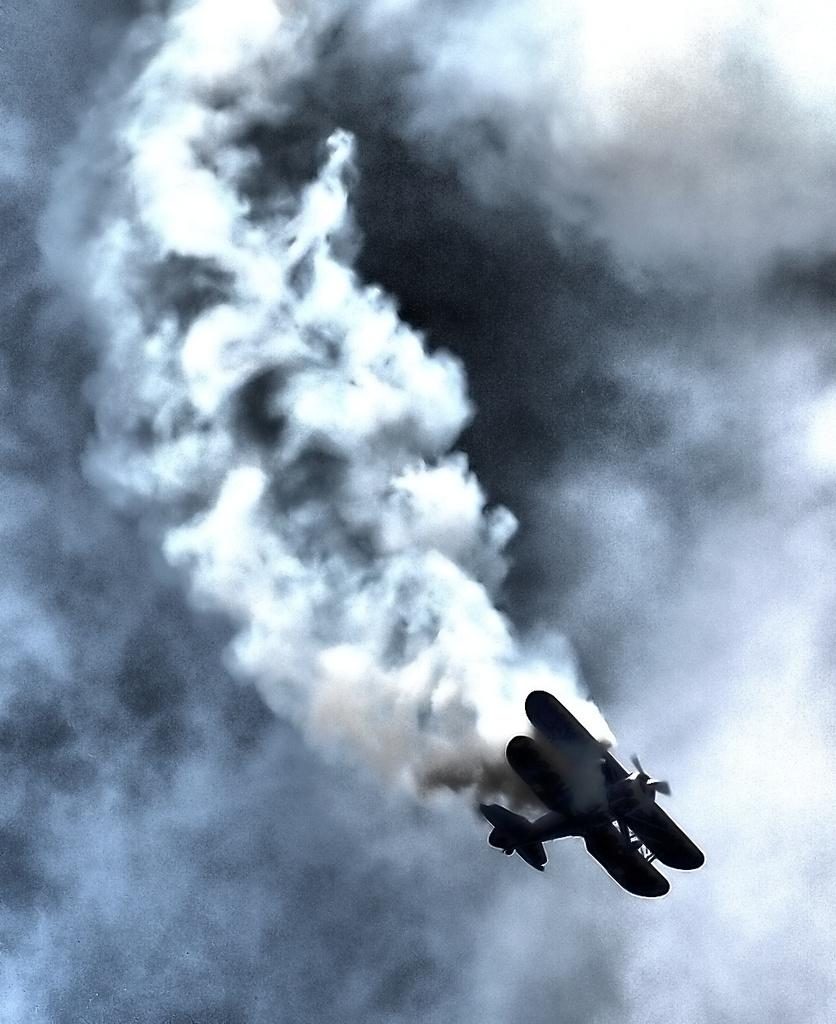What is the main subject of the image? The main subject of the image is an aircraft. What is the aircraft doing in the image? The aircraft is moving in the sky. What can be seen coming from the aircraft in the image? There is smoke visible in the image. What is the condition of the sky in the background of the image? The sky in the background of the image is cloudy. What type of skirt is the train wearing in the image? There is no train or skirt present in the image; it features an aircraft moving in the sky with smoke visible. 